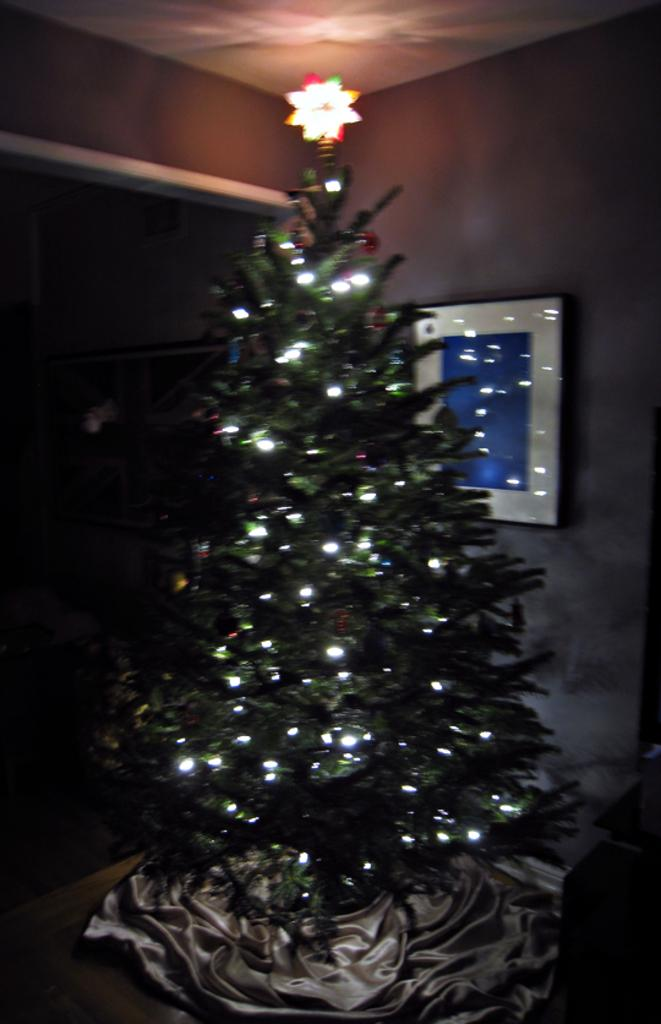What type of tree is in the image? There is a Christmas tree in the image. What object can be seen on the right side of the image? There is a photo frame on the right side of the image. What is visible at the top of the image? There is a ceiling at the top of the image. How many pizzas are being delivered by the father in the image? There is no father or pizzas present in the image. 